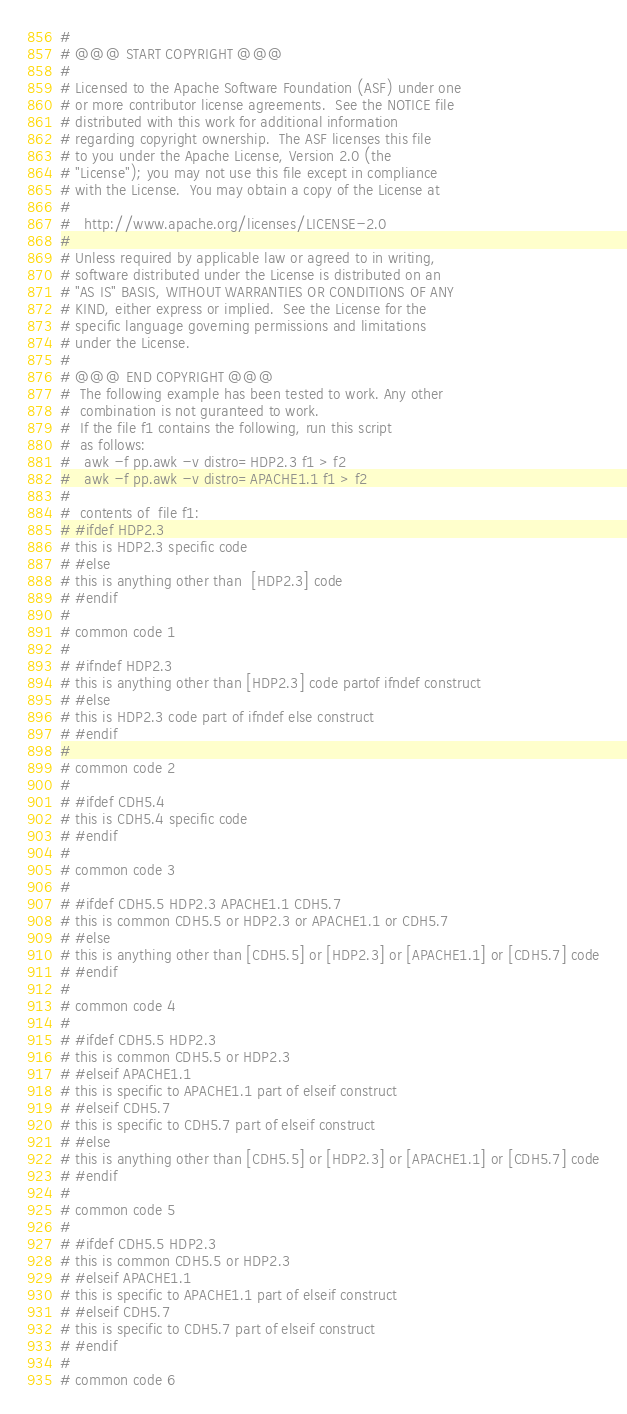Convert code to text. <code><loc_0><loc_0><loc_500><loc_500><_Awk_>#
# @@@ START COPYRIGHT @@@
#
# Licensed to the Apache Software Foundation (ASF) under one
# or more contributor license agreements.  See the NOTICE file
# distributed with this work for additional information
# regarding copyright ownership.  The ASF licenses this file
# to you under the Apache License, Version 2.0 (the
# "License"); you may not use this file except in compliance
# with the License.  You may obtain a copy of the License at
#
#   http://www.apache.org/licenses/LICENSE-2.0
#
# Unless required by applicable law or agreed to in writing,
# software distributed under the License is distributed on an
# "AS IS" BASIS, WITHOUT WARRANTIES OR CONDITIONS OF ANY
# KIND, either express or implied.  See the License for the
# specific language governing permissions and limitations
# under the License.
#
# @@@ END COPYRIGHT @@@
#  The following example has been tested to work. Any other
#  combination is not guranteed to work. 
#  If the file f1 contains the following, run this script
#  as follows:    
#   awk -f pp.awk -v distro=HDP2.3 f1 > f2
#   awk -f pp.awk -v distro=APACHE1.1 f1 > f2
#
#  contents of  file f1:
# #ifdef HDP2.3
# this is HDP2.3 specific code
# #else
# this is anything other than  [HDP2.3] code
# #endif
#
# common code 1
#
# #ifndef HDP2.3
# this is anything other than [HDP2.3] code partof ifndef construct
# #else
# this is HDP2.3 code part of ifndef else construct
# #endif
#
# common code 2
#
# #ifdef CDH5.4
# this is CDH5.4 specific code
# #endif
#
# common code 3
#
# #ifdef CDH5.5 HDP2.3 APACHE1.1 CDH5.7
# this is common CDH5.5 or HDP2.3 or APACHE1.1 or CDH5.7
# #else
# this is anything other than [CDH5.5] or [HDP2.3] or [APACHE1.1] or [CDH5.7] code
# #endif
#
# common code 4
#
# #ifdef CDH5.5 HDP2.3
# this is common CDH5.5 or HDP2.3
# #elseif APACHE1.1
# this is specific to APACHE1.1 part of elseif construct
# #elseif CDH5.7
# this is specific to CDH5.7 part of elseif construct
# #else
# this is anything other than [CDH5.5] or [HDP2.3] or [APACHE1.1] or [CDH5.7] code
# #endif
#
# common code 5
#
# #ifdef CDH5.5 HDP2.3
# this is common CDH5.5 or HDP2.3
# #elseif APACHE1.1
# this is specific to APACHE1.1 part of elseif construct
# #elseif CDH5.7
# this is specific to CDH5.7 part of elseif construct
# #endif
# 
# common code 6

</code> 